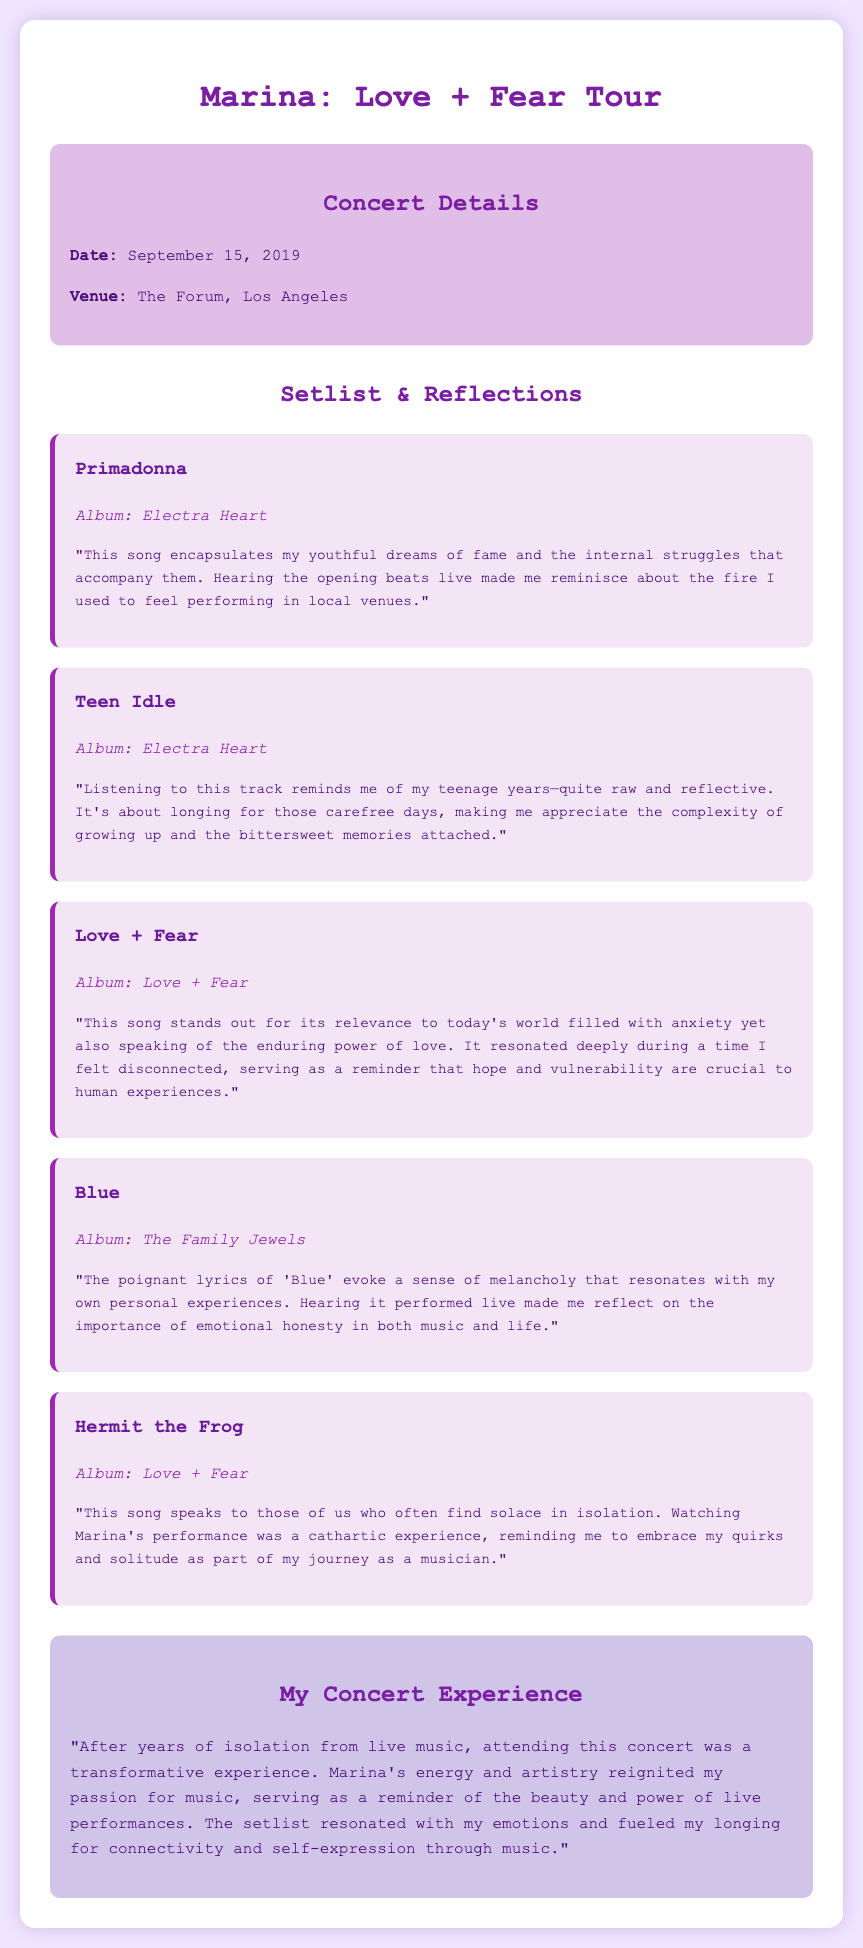what is the date of the concert? The date of the concert is detailed in the concert information section.
Answer: September 15, 2019 where was the concert held? The venue of the concert is mentioned in the concert information section.
Answer: The Forum, Los Angeles which song is performed first in the setlist? The first song is indicated at the top of the setlist section.
Answer: Primadonna what album is the song "Blue" from? The album of "Blue" is provided in the song details.
Answer: The Family Jewels how does the musician reflect on "Hermit the Frog"? Reflection on "Hermit the Frog" is provided in the document, explaining its significance to the musician.
Answer: Embrace my quirks and solitude what overall experience did the musician have at the concert? The musician's overall experience is summarized in a dedicated section about their concert experience.
Answer: Transformative experience 